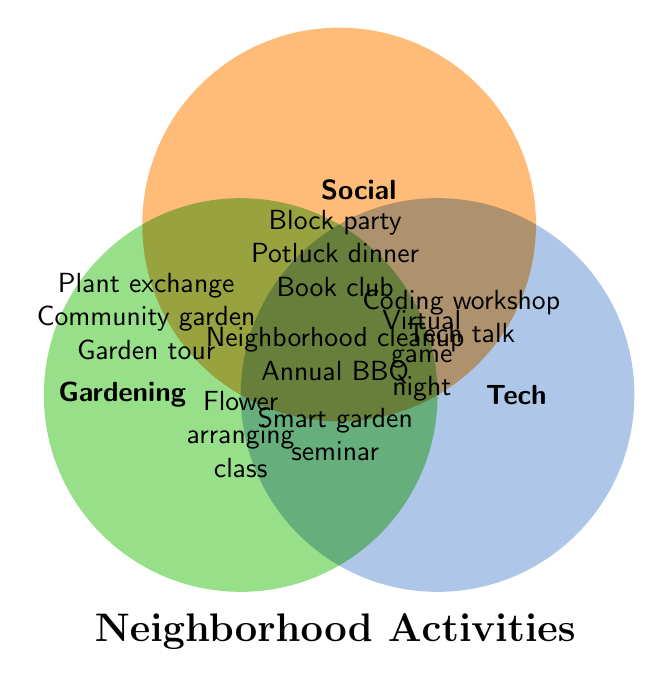What's the title of the diagram? Look at the text in a larger size at the bottom. It is labeled as "Neighborhood Activities".
Answer: Neighborhood Activities How many activities are in the "Gardening" category only? Identify the activities in the circle labeled "Gardening" that are not shared with any other circles.
Answer: 3 Which categories does the "Virtual game night" belong to? Find "Virtual game night" and see which overlapping circles it falls into. It is positioned where "Tech" and "Social" circles overlap.
Answer: Social and Tech Name two activities that involve all three categories. Look at the center where all three circles overlap. The activities listed there are "Neighborhood cleanup" and "Annual BBQ".
Answer: Neighborhood cleanup, Annual BBQ Are there more activities shared between "Gardening & Tech" or "Social & Tech"? Count the activities in the overlapping section between "Gardening & Tech" and "Social & Tech".
Answer: Social & Tech How many total activities are there? Sum all unique activities listed in all circles and overlapping sections. There are 3 unique in Gardening, 3 in Social, 2 in Tech, 1 in Gardening & Social, 1 in Gardening & Tech, 1 in Social & Tech, and 2 in All.
Answer: 13 Is "Smart garden seminar" shared among categories? Find "Smart garden seminar" and see if it falls in the overlapping section of multiple circles. It is in the overlap between Gardening and Tech.
Answer: Yes Which category has the most unique activities? Compare the number of unique activities in each circle. Gardening, Social, and Tech have 3, 3, and 2 unique activities respectively.
Answer: Gardening and Social Which category does "Community garden" fall into? Look at which circle "Community garden" is in without any overlap. It is solely in the Gardening category.
Answer: Gardening 